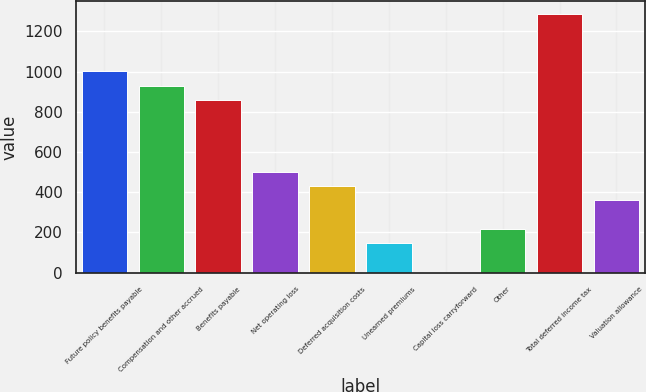<chart> <loc_0><loc_0><loc_500><loc_500><bar_chart><fcel>Future policy benefits payable<fcel>Compensation and other accrued<fcel>Benefits payable<fcel>Net operating loss<fcel>Deferred acquisition costs<fcel>Unearned premiums<fcel>Capital loss carryforward<fcel>Other<fcel>Total deferred income tax<fcel>Valuation allowance<nl><fcel>1001<fcel>929.75<fcel>858.5<fcel>502.25<fcel>431<fcel>146<fcel>3.5<fcel>217.25<fcel>1286<fcel>359.75<nl></chart> 